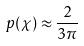Convert formula to latex. <formula><loc_0><loc_0><loc_500><loc_500>p ( \chi ) \approx \frac { 2 } { 3 \pi }</formula> 